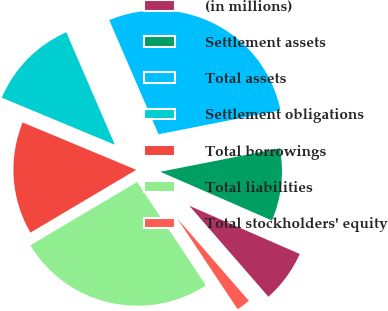<chart> <loc_0><loc_0><loc_500><loc_500><pie_chart><fcel>(in millions)<fcel>Settlement assets<fcel>Total assets<fcel>Settlement obligations<fcel>Total borrowings<fcel>Total liabilities<fcel>Total stockholders' equity<nl><fcel>7.06%<fcel>9.64%<fcel>28.4%<fcel>12.23%<fcel>14.81%<fcel>25.82%<fcel>2.05%<nl></chart> 